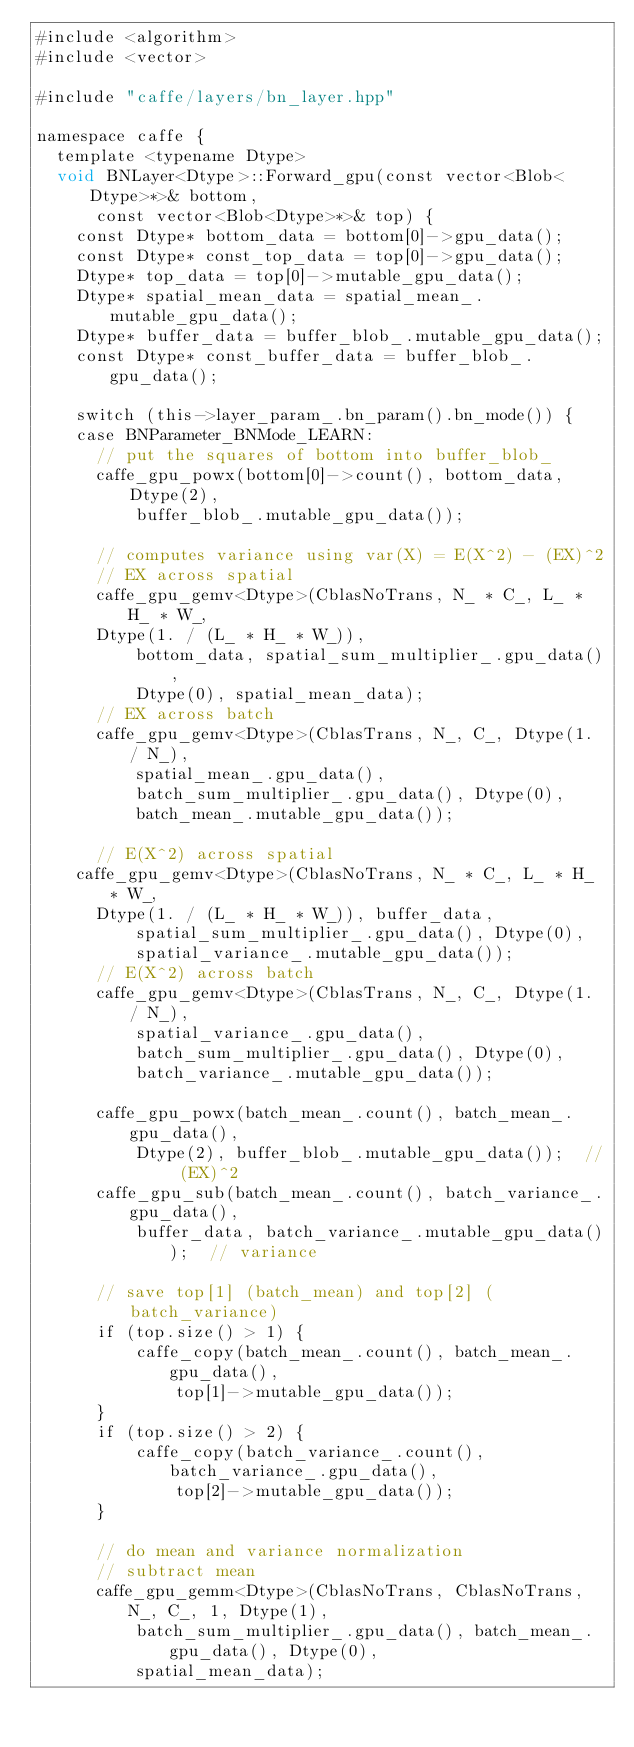<code> <loc_0><loc_0><loc_500><loc_500><_Cuda_>#include <algorithm>
#include <vector>

#include "caffe/layers/bn_layer.hpp"

namespace caffe {
  template <typename Dtype>
  void BNLayer<Dtype>::Forward_gpu(const vector<Blob<Dtype>*>& bottom,
      const vector<Blob<Dtype>*>& top) {
    const Dtype* bottom_data = bottom[0]->gpu_data();
    const Dtype* const_top_data = top[0]->gpu_data();
    Dtype* top_data = top[0]->mutable_gpu_data();
    Dtype* spatial_mean_data = spatial_mean_.mutable_gpu_data();
    Dtype* buffer_data = buffer_blob_.mutable_gpu_data();
    const Dtype* const_buffer_data = buffer_blob_.gpu_data();

    switch (this->layer_param_.bn_param().bn_mode()) {
    case BNParameter_BNMode_LEARN:
      // put the squares of bottom into buffer_blob_
      caffe_gpu_powx(bottom[0]->count(), bottom_data, Dtype(2),
          buffer_blob_.mutable_gpu_data());

      // computes variance using var(X) = E(X^2) - (EX)^2
      // EX across spatial
      caffe_gpu_gemv<Dtype>(CblasNoTrans, N_ * C_, L_ * H_ * W_,
		  Dtype(1. / (L_ * H_ * W_)),
          bottom_data, spatial_sum_multiplier_.gpu_data(),
          Dtype(0), spatial_mean_data);
      // EX across batch
      caffe_gpu_gemv<Dtype>(CblasTrans, N_, C_, Dtype(1. / N_),
          spatial_mean_.gpu_data(),
          batch_sum_multiplier_.gpu_data(), Dtype(0),
          batch_mean_.mutable_gpu_data());

      // E(X^2) across spatial
	  caffe_gpu_gemv<Dtype>(CblasNoTrans, N_ * C_, L_ * H_ * W_,
		  Dtype(1. / (L_ * H_ * W_)), buffer_data,
          spatial_sum_multiplier_.gpu_data(), Dtype(0),
          spatial_variance_.mutable_gpu_data());
      // E(X^2) across batch
      caffe_gpu_gemv<Dtype>(CblasTrans, N_, C_, Dtype(1. / N_),
          spatial_variance_.gpu_data(),
          batch_sum_multiplier_.gpu_data(), Dtype(0),
          batch_variance_.mutable_gpu_data());

      caffe_gpu_powx(batch_mean_.count(), batch_mean_.gpu_data(),
          Dtype(2), buffer_blob_.mutable_gpu_data());  // (EX)^2
      caffe_gpu_sub(batch_mean_.count(), batch_variance_.gpu_data(),
          buffer_data, batch_variance_.mutable_gpu_data());  // variance

      // save top[1] (batch_mean) and top[2] (batch_variance)
      if (top.size() > 1) {
          caffe_copy(batch_mean_.count(), batch_mean_.gpu_data(),
              top[1]->mutable_gpu_data());
      }
      if (top.size() > 2) {
          caffe_copy(batch_variance_.count(), batch_variance_.gpu_data(),
              top[2]->mutable_gpu_data());
      }

      // do mean and variance normalization
      // subtract mean
      caffe_gpu_gemm<Dtype>(CblasNoTrans, CblasNoTrans, N_, C_, 1, Dtype(1),
          batch_sum_multiplier_.gpu_data(), batch_mean_.gpu_data(), Dtype(0),
          spatial_mean_data);</code> 